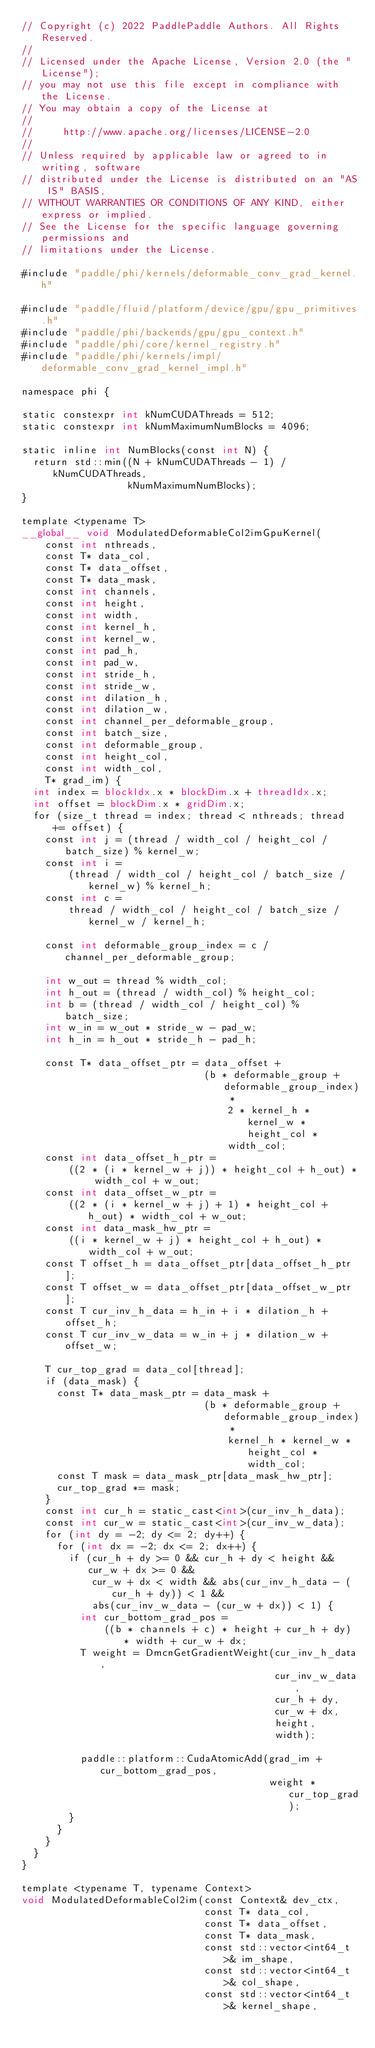<code> <loc_0><loc_0><loc_500><loc_500><_Cuda_>// Copyright (c) 2022 PaddlePaddle Authors. All Rights Reserved.
//
// Licensed under the Apache License, Version 2.0 (the "License");
// you may not use this file except in compliance with the License.
// You may obtain a copy of the License at
//
//     http://www.apache.org/licenses/LICENSE-2.0
//
// Unless required by applicable law or agreed to in writing, software
// distributed under the License is distributed on an "AS IS" BASIS,
// WITHOUT WARRANTIES OR CONDITIONS OF ANY KIND, either express or implied.
// See the License for the specific language governing permissions and
// limitations under the License.

#include "paddle/phi/kernels/deformable_conv_grad_kernel.h"

#include "paddle/fluid/platform/device/gpu/gpu_primitives.h"
#include "paddle/phi/backends/gpu/gpu_context.h"
#include "paddle/phi/core/kernel_registry.h"
#include "paddle/phi/kernels/impl/deformable_conv_grad_kernel_impl.h"

namespace phi {

static constexpr int kNumCUDAThreads = 512;
static constexpr int kNumMaximumNumBlocks = 4096;

static inline int NumBlocks(const int N) {
  return std::min((N + kNumCUDAThreads - 1) / kNumCUDAThreads,
                  kNumMaximumNumBlocks);
}

template <typename T>
__global__ void ModulatedDeformableCol2imGpuKernel(
    const int nthreads,
    const T* data_col,
    const T* data_offset,
    const T* data_mask,
    const int channels,
    const int height,
    const int width,
    const int kernel_h,
    const int kernel_w,
    const int pad_h,
    const int pad_w,
    const int stride_h,
    const int stride_w,
    const int dilation_h,
    const int dilation_w,
    const int channel_per_deformable_group,
    const int batch_size,
    const int deformable_group,
    const int height_col,
    const int width_col,
    T* grad_im) {
  int index = blockIdx.x * blockDim.x + threadIdx.x;
  int offset = blockDim.x * gridDim.x;
  for (size_t thread = index; thread < nthreads; thread += offset) {
    const int j = (thread / width_col / height_col / batch_size) % kernel_w;
    const int i =
        (thread / width_col / height_col / batch_size / kernel_w) % kernel_h;
    const int c =
        thread / width_col / height_col / batch_size / kernel_w / kernel_h;

    const int deformable_group_index = c / channel_per_deformable_group;

    int w_out = thread % width_col;
    int h_out = (thread / width_col) % height_col;
    int b = (thread / width_col / height_col) % batch_size;
    int w_in = w_out * stride_w - pad_w;
    int h_in = h_out * stride_h - pad_h;

    const T* data_offset_ptr = data_offset +
                               (b * deformable_group + deformable_group_index) *
                                   2 * kernel_h * kernel_w * height_col *
                                   width_col;
    const int data_offset_h_ptr =
        ((2 * (i * kernel_w + j)) * height_col + h_out) * width_col + w_out;
    const int data_offset_w_ptr =
        ((2 * (i * kernel_w + j) + 1) * height_col + h_out) * width_col + w_out;
    const int data_mask_hw_ptr =
        ((i * kernel_w + j) * height_col + h_out) * width_col + w_out;
    const T offset_h = data_offset_ptr[data_offset_h_ptr];
    const T offset_w = data_offset_ptr[data_offset_w_ptr];
    const T cur_inv_h_data = h_in + i * dilation_h + offset_h;
    const T cur_inv_w_data = w_in + j * dilation_w + offset_w;

    T cur_top_grad = data_col[thread];
    if (data_mask) {
      const T* data_mask_ptr = data_mask +
                               (b * deformable_group + deformable_group_index) *
                                   kernel_h * kernel_w * height_col * width_col;
      const T mask = data_mask_ptr[data_mask_hw_ptr];
      cur_top_grad *= mask;
    }
    const int cur_h = static_cast<int>(cur_inv_h_data);
    const int cur_w = static_cast<int>(cur_inv_w_data);
    for (int dy = -2; dy <= 2; dy++) {
      for (int dx = -2; dx <= 2; dx++) {
        if (cur_h + dy >= 0 && cur_h + dy < height && cur_w + dx >= 0 &&
            cur_w + dx < width && abs(cur_inv_h_data - (cur_h + dy)) < 1 &&
            abs(cur_inv_w_data - (cur_w + dx)) < 1) {
          int cur_bottom_grad_pos =
              ((b * channels + c) * height + cur_h + dy) * width + cur_w + dx;
          T weight = DmcnGetGradientWeight(cur_inv_h_data,
                                           cur_inv_w_data,
                                           cur_h + dy,
                                           cur_w + dx,
                                           height,
                                           width);

          paddle::platform::CudaAtomicAdd(grad_im + cur_bottom_grad_pos,
                                          weight * cur_top_grad);
        }
      }
    }
  }
}

template <typename T, typename Context>
void ModulatedDeformableCol2im(const Context& dev_ctx,
                               const T* data_col,
                               const T* data_offset,
                               const T* data_mask,
                               const std::vector<int64_t>& im_shape,
                               const std::vector<int64_t>& col_shape,
                               const std::vector<int64_t>& kernel_shape,</code> 